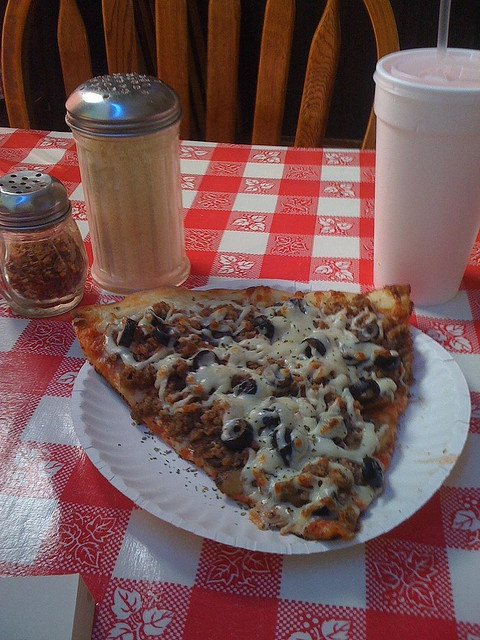Describe the objects in this image and their specific colors. I can see dining table in black, maroon, gray, darkgray, and brown tones, pizza in black, gray, and maroon tones, chair in black, maroon, and brown tones, cup in black, gray, and darkgray tones, and bottle in black, maroon, gray, and brown tones in this image. 